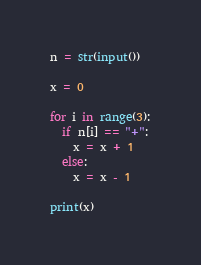Convert code to text. <code><loc_0><loc_0><loc_500><loc_500><_Python_>n = str(input())

x = 0

for i in range(3):
  if n[i] == "+":
    x = x + 1
  else:
    x = x - 1
    
print(x)

</code> 